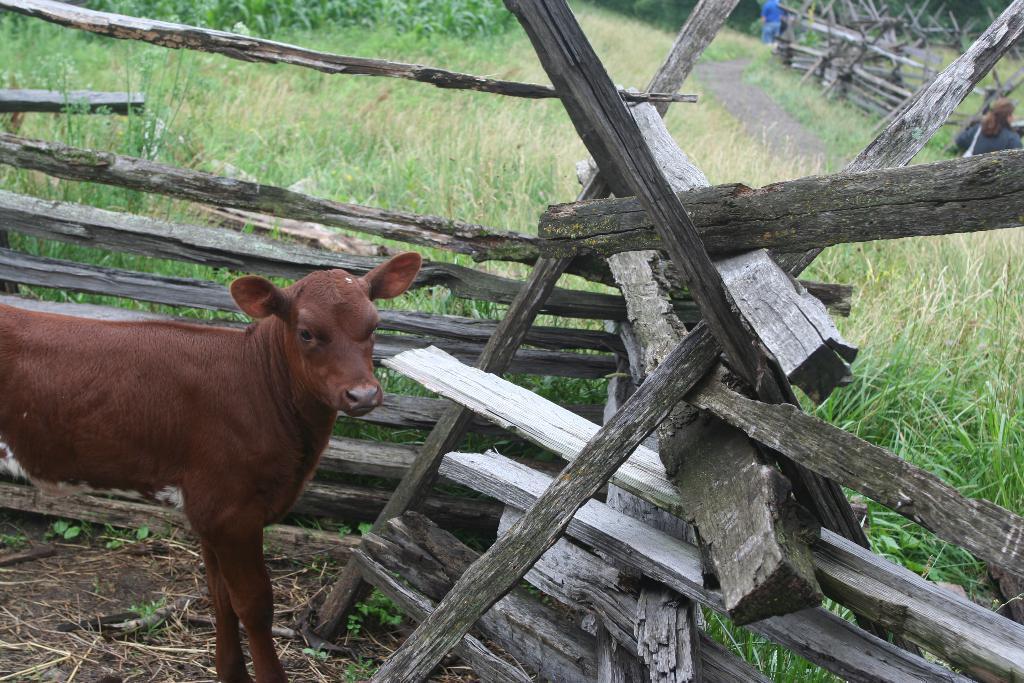Could you give a brief overview of what you see in this image? In this picture I can see animal on the surface. I can see wooden fence. I can see green grass. I can see people on the right side. 